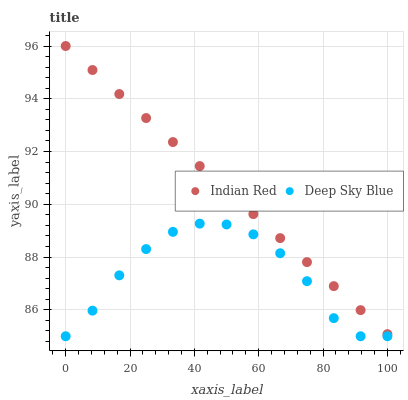Does Deep Sky Blue have the minimum area under the curve?
Answer yes or no. Yes. Does Indian Red have the maximum area under the curve?
Answer yes or no. Yes. Does Indian Red have the minimum area under the curve?
Answer yes or no. No. Is Indian Red the smoothest?
Answer yes or no. Yes. Is Deep Sky Blue the roughest?
Answer yes or no. Yes. Is Indian Red the roughest?
Answer yes or no. No. Does Deep Sky Blue have the lowest value?
Answer yes or no. Yes. Does Indian Red have the lowest value?
Answer yes or no. No. Does Indian Red have the highest value?
Answer yes or no. Yes. Is Deep Sky Blue less than Indian Red?
Answer yes or no. Yes. Is Indian Red greater than Deep Sky Blue?
Answer yes or no. Yes. Does Deep Sky Blue intersect Indian Red?
Answer yes or no. No. 